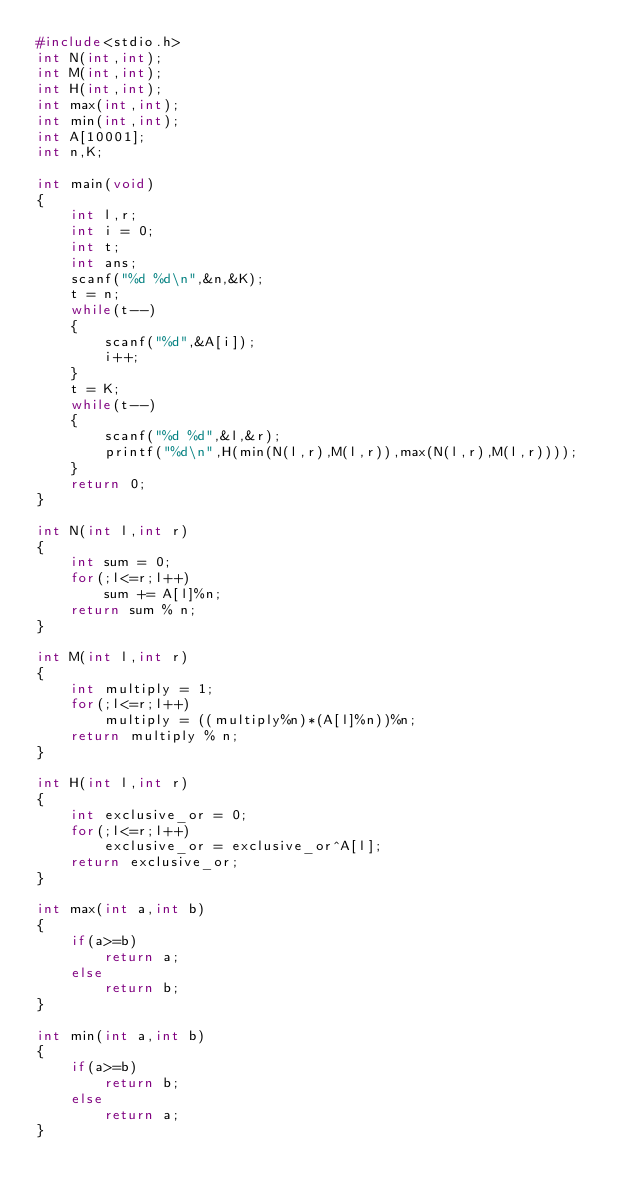<code> <loc_0><loc_0><loc_500><loc_500><_C_>#include<stdio.h>
int N(int,int);
int M(int,int);
int H(int,int);
int max(int,int);
int min(int,int);
int A[10001];
int n,K;

int main(void)
{
    int l,r;
    int i = 0;
    int t;
    int ans;
    scanf("%d %d\n",&n,&K);
    t = n;
    while(t--)
    {
        scanf("%d",&A[i]);
        i++;
    }
    t = K;
    while(t--)
    {
        scanf("%d %d",&l,&r);
        printf("%d\n",H(min(N(l,r),M(l,r)),max(N(l,r),M(l,r))));
    }
    return 0;
}

int N(int l,int r)
{
    int sum = 0;
    for(;l<=r;l++)
        sum += A[l]%n;
    return sum % n;
}

int M(int l,int r)
{
    int multiply = 1;
    for(;l<=r;l++)
        multiply = ((multiply%n)*(A[l]%n))%n;
    return multiply % n;
}

int H(int l,int r)
{
    int exclusive_or = 0;
    for(;l<=r;l++)
        exclusive_or = exclusive_or^A[l];
    return exclusive_or;
}

int max(int a,int b)
{
    if(a>=b)
        return a;
    else
        return b;
}

int min(int a,int b)
{
    if(a>=b)
        return b;
    else
        return a;
}</code> 